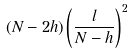Convert formula to latex. <formula><loc_0><loc_0><loc_500><loc_500>( N - 2 h ) \left ( \frac { l } { N - h } \right ) ^ { 2 }</formula> 